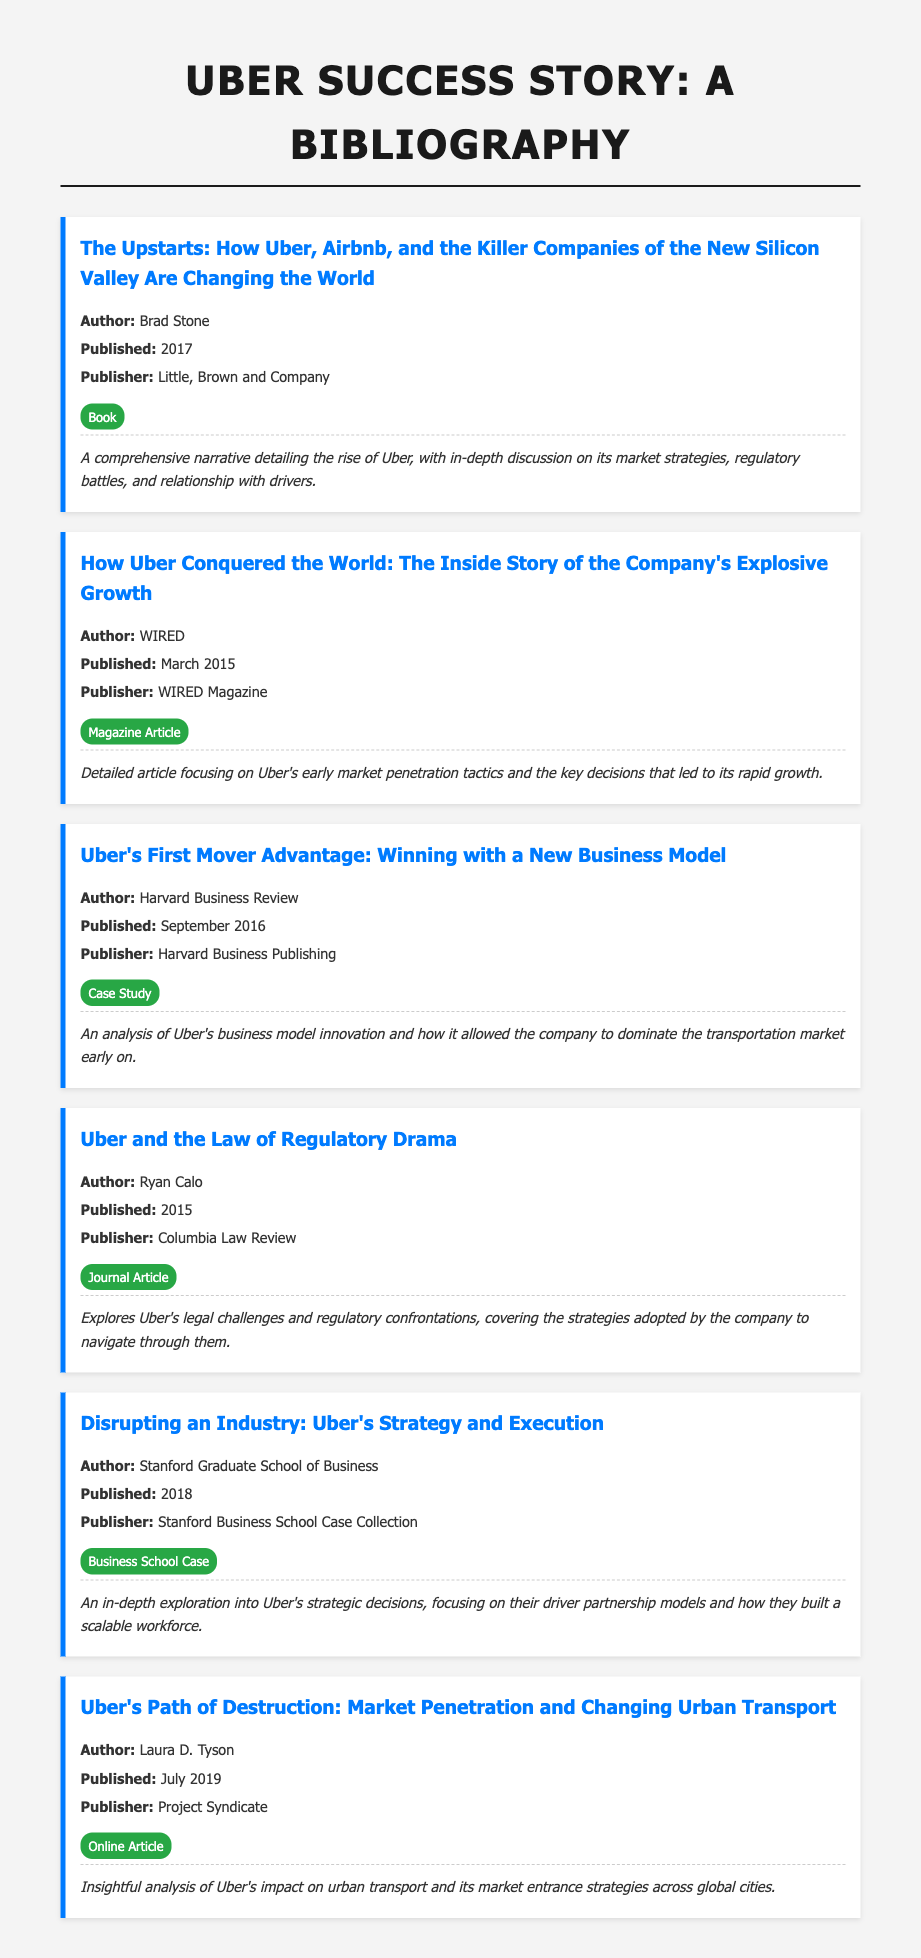What is the title of Brad Stone's book? The title is found in the first bibliography item, detailing Uber's rise and market strategies.
Answer: The Upstarts: How Uber, Airbnb, and the Killer Companies of the New Silicon Valley Are Changing the World Who published the article "Uber and the Law of Regulatory Drama"? The publisher is stated in the fourth bibliography item that focuses on Uber's legal challenges.
Answer: Columbia Law Review When was "How Uber Conquered the World" published? The publication date is included in the second bibliography item for WIRED's article on Uber.
Answer: March 2015 What type of document is "Uber's Path of Destruction"? The type is indicated in the last bibliography item that analyzes Uber's impact on urban transport.
Answer: Online Article What year was the case study published by Harvard Business Review? The year is mentioned in the third bibliography item discussing Uber's business model innovation.
Answer: September 2016 Which author analyzed Uber's business model innovation? The author is identified in the third bibliography item related to business model analysis.
Answer: Harvard Business Review What key theme does "Disrupting an Industry" focus on? The theme is described in the summary of the fifth bibliography item exploring strategic decisions.
Answer: Driver partnership models How many bibliography items feature a publication from 2018? The count can be determined by examining the publication years listed in the document.
Answer: 1 